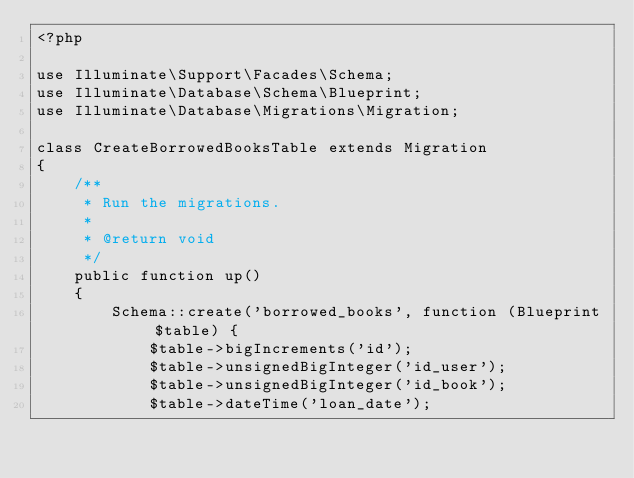<code> <loc_0><loc_0><loc_500><loc_500><_PHP_><?php

use Illuminate\Support\Facades\Schema;
use Illuminate\Database\Schema\Blueprint;
use Illuminate\Database\Migrations\Migration;

class CreateBorrowedBooksTable extends Migration
{
    /**
     * Run the migrations.
     *
     * @return void
     */
    public function up()
    {
        Schema::create('borrowed_books', function (Blueprint $table) {
            $table->bigIncrements('id');
            $table->unsignedBigInteger('id_user');
            $table->unsignedBigInteger('id_book');
            $table->dateTime('loan_date');</code> 